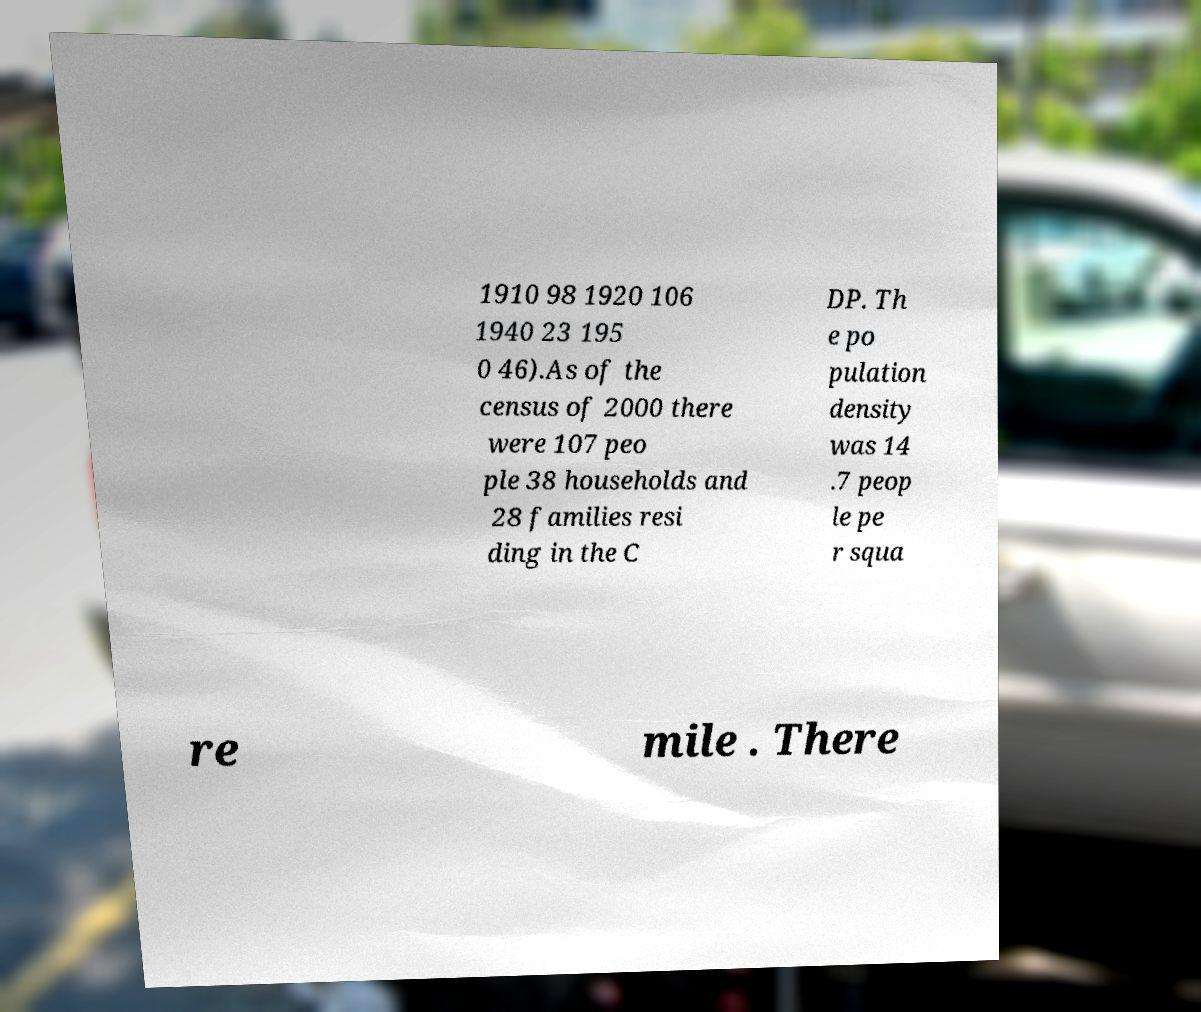Can you read and provide the text displayed in the image?This photo seems to have some interesting text. Can you extract and type it out for me? 1910 98 1920 106 1940 23 195 0 46).As of the census of 2000 there were 107 peo ple 38 households and 28 families resi ding in the C DP. Th e po pulation density was 14 .7 peop le pe r squa re mile . There 